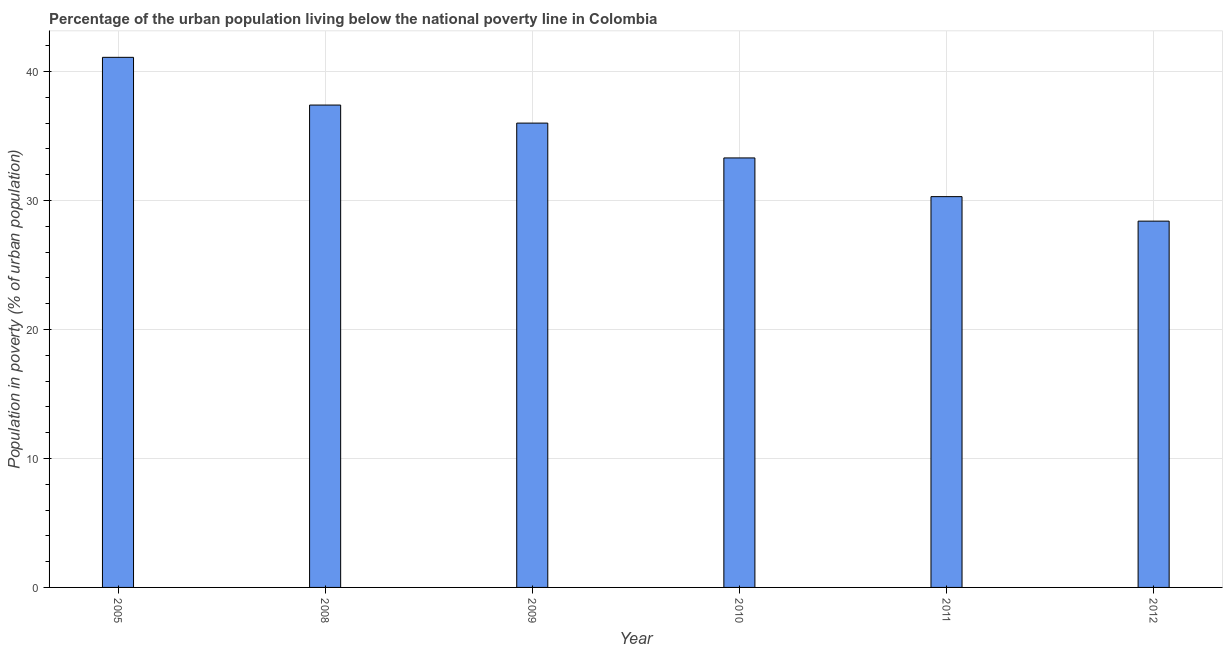Does the graph contain grids?
Provide a short and direct response. Yes. What is the title of the graph?
Keep it short and to the point. Percentage of the urban population living below the national poverty line in Colombia. What is the label or title of the X-axis?
Your answer should be very brief. Year. What is the label or title of the Y-axis?
Provide a short and direct response. Population in poverty (% of urban population). What is the percentage of urban population living below poverty line in 2011?
Your answer should be very brief. 30.3. Across all years, what is the maximum percentage of urban population living below poverty line?
Provide a short and direct response. 41.1. Across all years, what is the minimum percentage of urban population living below poverty line?
Your answer should be very brief. 28.4. What is the sum of the percentage of urban population living below poverty line?
Your response must be concise. 206.5. What is the average percentage of urban population living below poverty line per year?
Give a very brief answer. 34.42. What is the median percentage of urban population living below poverty line?
Provide a short and direct response. 34.65. Do a majority of the years between 2011 and 2005 (inclusive) have percentage of urban population living below poverty line greater than 34 %?
Your answer should be very brief. Yes. What is the ratio of the percentage of urban population living below poverty line in 2008 to that in 2012?
Your response must be concise. 1.32. Is the difference between the percentage of urban population living below poverty line in 2005 and 2010 greater than the difference between any two years?
Your answer should be compact. No. What is the difference between the highest and the second highest percentage of urban population living below poverty line?
Your answer should be very brief. 3.7. Is the sum of the percentage of urban population living below poverty line in 2009 and 2010 greater than the maximum percentage of urban population living below poverty line across all years?
Offer a terse response. Yes. What is the difference between the highest and the lowest percentage of urban population living below poverty line?
Keep it short and to the point. 12.7. How many bars are there?
Your response must be concise. 6. What is the difference between two consecutive major ticks on the Y-axis?
Your answer should be compact. 10. What is the Population in poverty (% of urban population) in 2005?
Your answer should be very brief. 41.1. What is the Population in poverty (% of urban population) in 2008?
Offer a very short reply. 37.4. What is the Population in poverty (% of urban population) in 2009?
Ensure brevity in your answer.  36. What is the Population in poverty (% of urban population) of 2010?
Your answer should be compact. 33.3. What is the Population in poverty (% of urban population) in 2011?
Your answer should be compact. 30.3. What is the Population in poverty (% of urban population) of 2012?
Your answer should be very brief. 28.4. What is the difference between the Population in poverty (% of urban population) in 2005 and 2008?
Offer a very short reply. 3.7. What is the difference between the Population in poverty (% of urban population) in 2005 and 2010?
Your answer should be compact. 7.8. What is the difference between the Population in poverty (% of urban population) in 2005 and 2011?
Your answer should be compact. 10.8. What is the difference between the Population in poverty (% of urban population) in 2005 and 2012?
Offer a terse response. 12.7. What is the difference between the Population in poverty (% of urban population) in 2008 and 2009?
Your answer should be very brief. 1.4. What is the difference between the Population in poverty (% of urban population) in 2008 and 2010?
Provide a short and direct response. 4.1. What is the difference between the Population in poverty (% of urban population) in 2008 and 2012?
Give a very brief answer. 9. What is the difference between the Population in poverty (% of urban population) in 2009 and 2012?
Provide a short and direct response. 7.6. What is the difference between the Population in poverty (% of urban population) in 2010 and 2012?
Your answer should be very brief. 4.9. What is the ratio of the Population in poverty (% of urban population) in 2005 to that in 2008?
Your answer should be compact. 1.1. What is the ratio of the Population in poverty (% of urban population) in 2005 to that in 2009?
Give a very brief answer. 1.14. What is the ratio of the Population in poverty (% of urban population) in 2005 to that in 2010?
Provide a succinct answer. 1.23. What is the ratio of the Population in poverty (% of urban population) in 2005 to that in 2011?
Ensure brevity in your answer.  1.36. What is the ratio of the Population in poverty (% of urban population) in 2005 to that in 2012?
Your response must be concise. 1.45. What is the ratio of the Population in poverty (% of urban population) in 2008 to that in 2009?
Make the answer very short. 1.04. What is the ratio of the Population in poverty (% of urban population) in 2008 to that in 2010?
Make the answer very short. 1.12. What is the ratio of the Population in poverty (% of urban population) in 2008 to that in 2011?
Offer a terse response. 1.23. What is the ratio of the Population in poverty (% of urban population) in 2008 to that in 2012?
Ensure brevity in your answer.  1.32. What is the ratio of the Population in poverty (% of urban population) in 2009 to that in 2010?
Provide a succinct answer. 1.08. What is the ratio of the Population in poverty (% of urban population) in 2009 to that in 2011?
Ensure brevity in your answer.  1.19. What is the ratio of the Population in poverty (% of urban population) in 2009 to that in 2012?
Your response must be concise. 1.27. What is the ratio of the Population in poverty (% of urban population) in 2010 to that in 2011?
Offer a very short reply. 1.1. What is the ratio of the Population in poverty (% of urban population) in 2010 to that in 2012?
Give a very brief answer. 1.17. What is the ratio of the Population in poverty (% of urban population) in 2011 to that in 2012?
Keep it short and to the point. 1.07. 